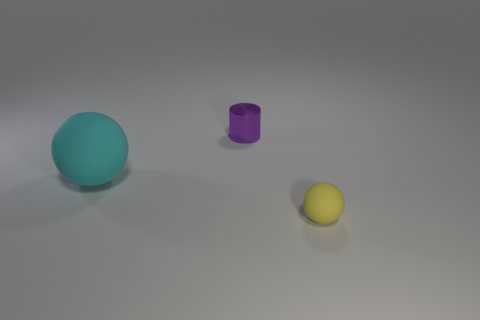Add 3 large spheres. How many objects exist? 6 Subtract all balls. How many objects are left? 1 Add 3 large cyan rubber balls. How many large cyan rubber balls are left? 4 Add 1 purple cylinders. How many purple cylinders exist? 2 Subtract 0 green blocks. How many objects are left? 3 Subtract all matte objects. Subtract all small purple shiny cylinders. How many objects are left? 0 